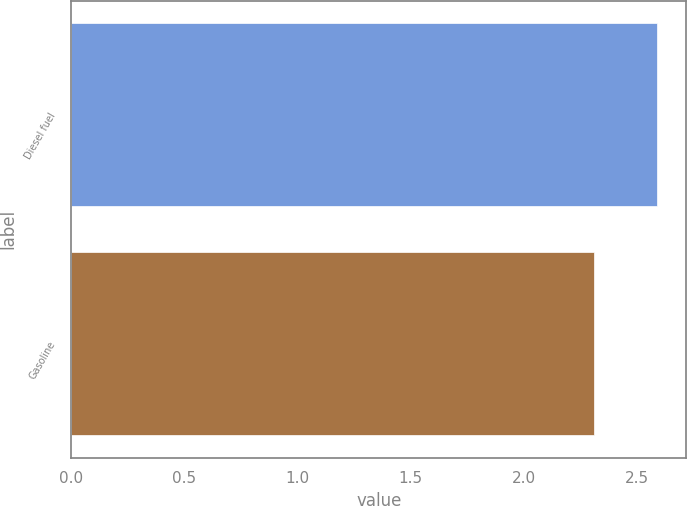Convert chart. <chart><loc_0><loc_0><loc_500><loc_500><bar_chart><fcel>Diesel fuel<fcel>Gasoline<nl><fcel>2.59<fcel>2.31<nl></chart> 